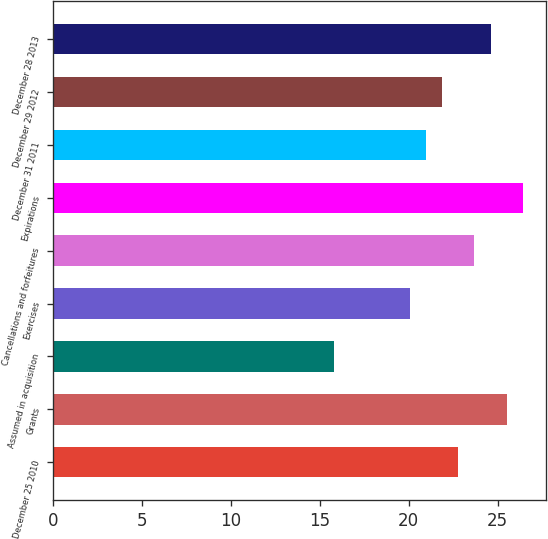Convert chart. <chart><loc_0><loc_0><loc_500><loc_500><bar_chart><fcel>December 25 2010<fcel>Grants<fcel>Assumed in acquisition<fcel>Exercises<fcel>Cancellations and forfeitures<fcel>Expirations<fcel>December 31 2011<fcel>December 29 2012<fcel>December 28 2013<nl><fcel>22.78<fcel>25.51<fcel>15.8<fcel>20.06<fcel>23.69<fcel>26.42<fcel>20.96<fcel>21.87<fcel>24.6<nl></chart> 